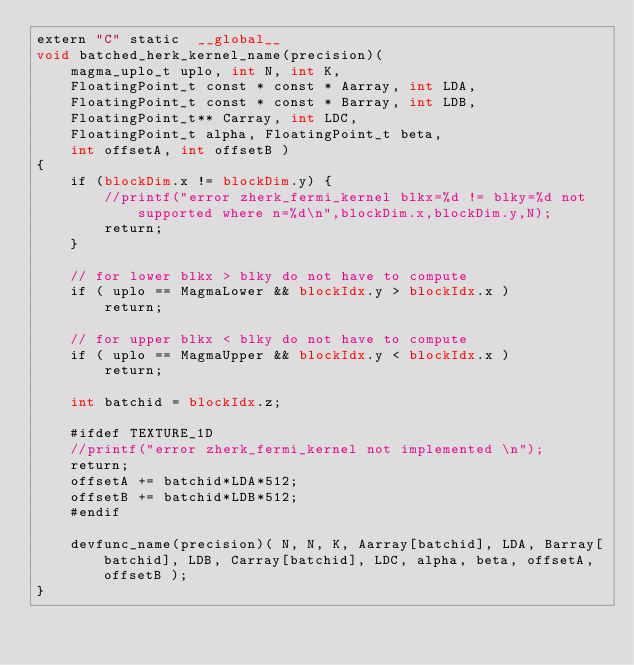Convert code to text. <code><loc_0><loc_0><loc_500><loc_500><_Cuda_>extern "C" static  __global__
void batched_herk_kernel_name(precision)(
    magma_uplo_t uplo, int N, int K,
    FloatingPoint_t const * const * Aarray, int LDA,
    FloatingPoint_t const * const * Barray, int LDB,
    FloatingPoint_t** Carray, int LDC,
    FloatingPoint_t alpha, FloatingPoint_t beta,
    int offsetA, int offsetB )
{
    if (blockDim.x != blockDim.y) {
        //printf("error zherk_fermi_kernel blkx=%d != blky=%d not supported where n=%d\n",blockDim.x,blockDim.y,N);
        return;
    }

    // for lower blkx > blky do not have to compute
    if ( uplo == MagmaLower && blockIdx.y > blockIdx.x )
        return;
    
    // for upper blkx < blky do not have to compute
    if ( uplo == MagmaUpper && blockIdx.y < blockIdx.x )
        return;

    int batchid = blockIdx.z;
    
    #ifdef TEXTURE_1D
    //printf("error zherk_fermi_kernel not implemented \n");
    return;
    offsetA += batchid*LDA*512;
    offsetB += batchid*LDB*512;
    #endif
    
    devfunc_name(precision)( N, N, K, Aarray[batchid], LDA, Barray[batchid], LDB, Carray[batchid], LDC, alpha, beta, offsetA, offsetB );
}
</code> 